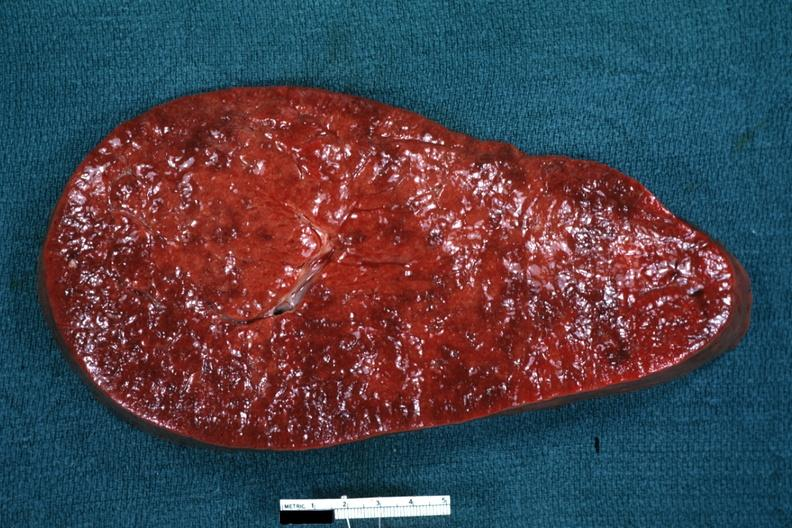s benign cystic teratoma present?
Answer the question using a single word or phrase. No 